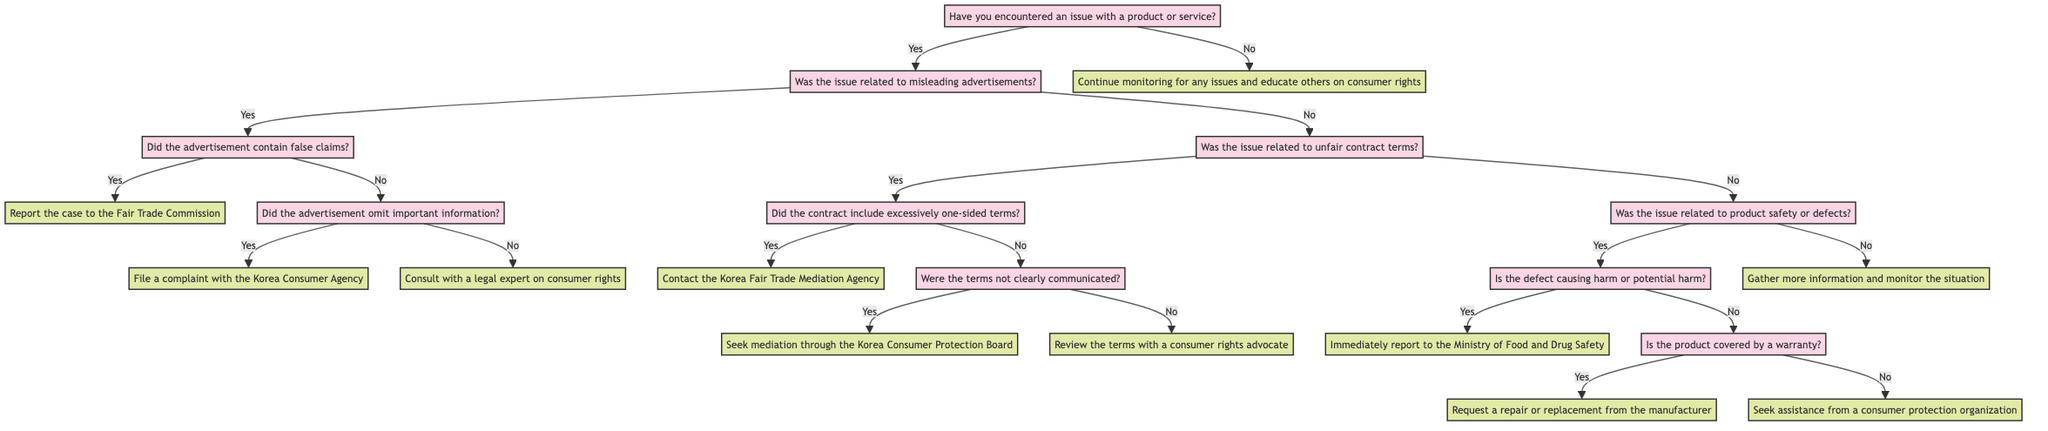What is the initial question in the decision tree? The diagram starts with the question "Have you encountered an issue with a product or service?" This is the first node in the decision tree that determines the flow of the entire decision process.
Answer: Have you encountered an issue with a product or service? How many actions are specified in the decision tree? By counting each end node that provides an action, we can see there are nine distinct actions listed within the decision tree.
Answer: Nine What is the action if the issue was related to misleading advertisements and contained false claims? The decision tree specifies that if an advertisement contains false claims, the next action is to "Report the case to the Fair Trade Commission." This is a direct outcome from that specific question.
Answer: Report the case to the Fair Trade Commission What should you do if the contract terms were not clearly communicated? Following the decision tree's path, if the terms were not clearly communicated in an unfair contract situation, the action to take is to "Seek mediation through the Korea Consumer Protection Board." This leverages the previous decision made concerning contract terms.
Answer: Seek mediation through the Korea Consumer Protection Board What is the last action if there was no issue encountered? If the initial question determines that no issue was encountered, the flow of the decision tree concludes with the action to "Continue monitoring for any issues and educate others on consumer rights." This signifies the closure of the process without an actionable complaint.
Answer: Continue monitoring for any issues and educate others on consumer rights If the product's defect is not causing harm and is not covered by a warranty, what is the next step? In this scenario, the decision tree indicates that if a product defect is present but is not harmful and is also not under warranty, the action to take is to "Seek assistance from a consumer protection organization." This combines the assessments of warranty coverage and potential harm.
Answer: Seek assistance from a consumer protection organization 